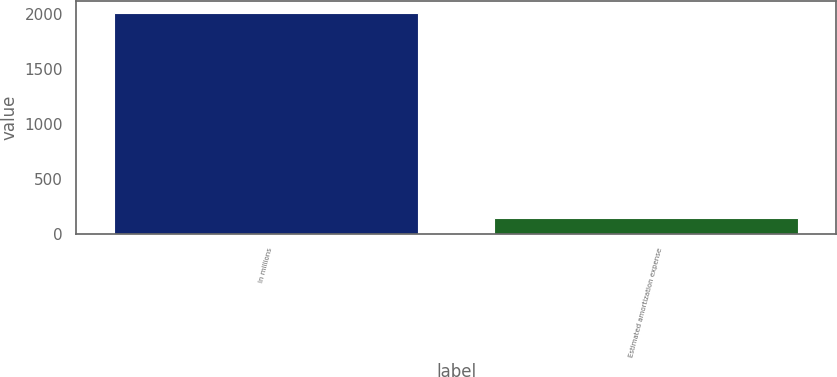Convert chart. <chart><loc_0><loc_0><loc_500><loc_500><bar_chart><fcel>In millions<fcel>Estimated amortization expense<nl><fcel>2017<fcel>148<nl></chart> 